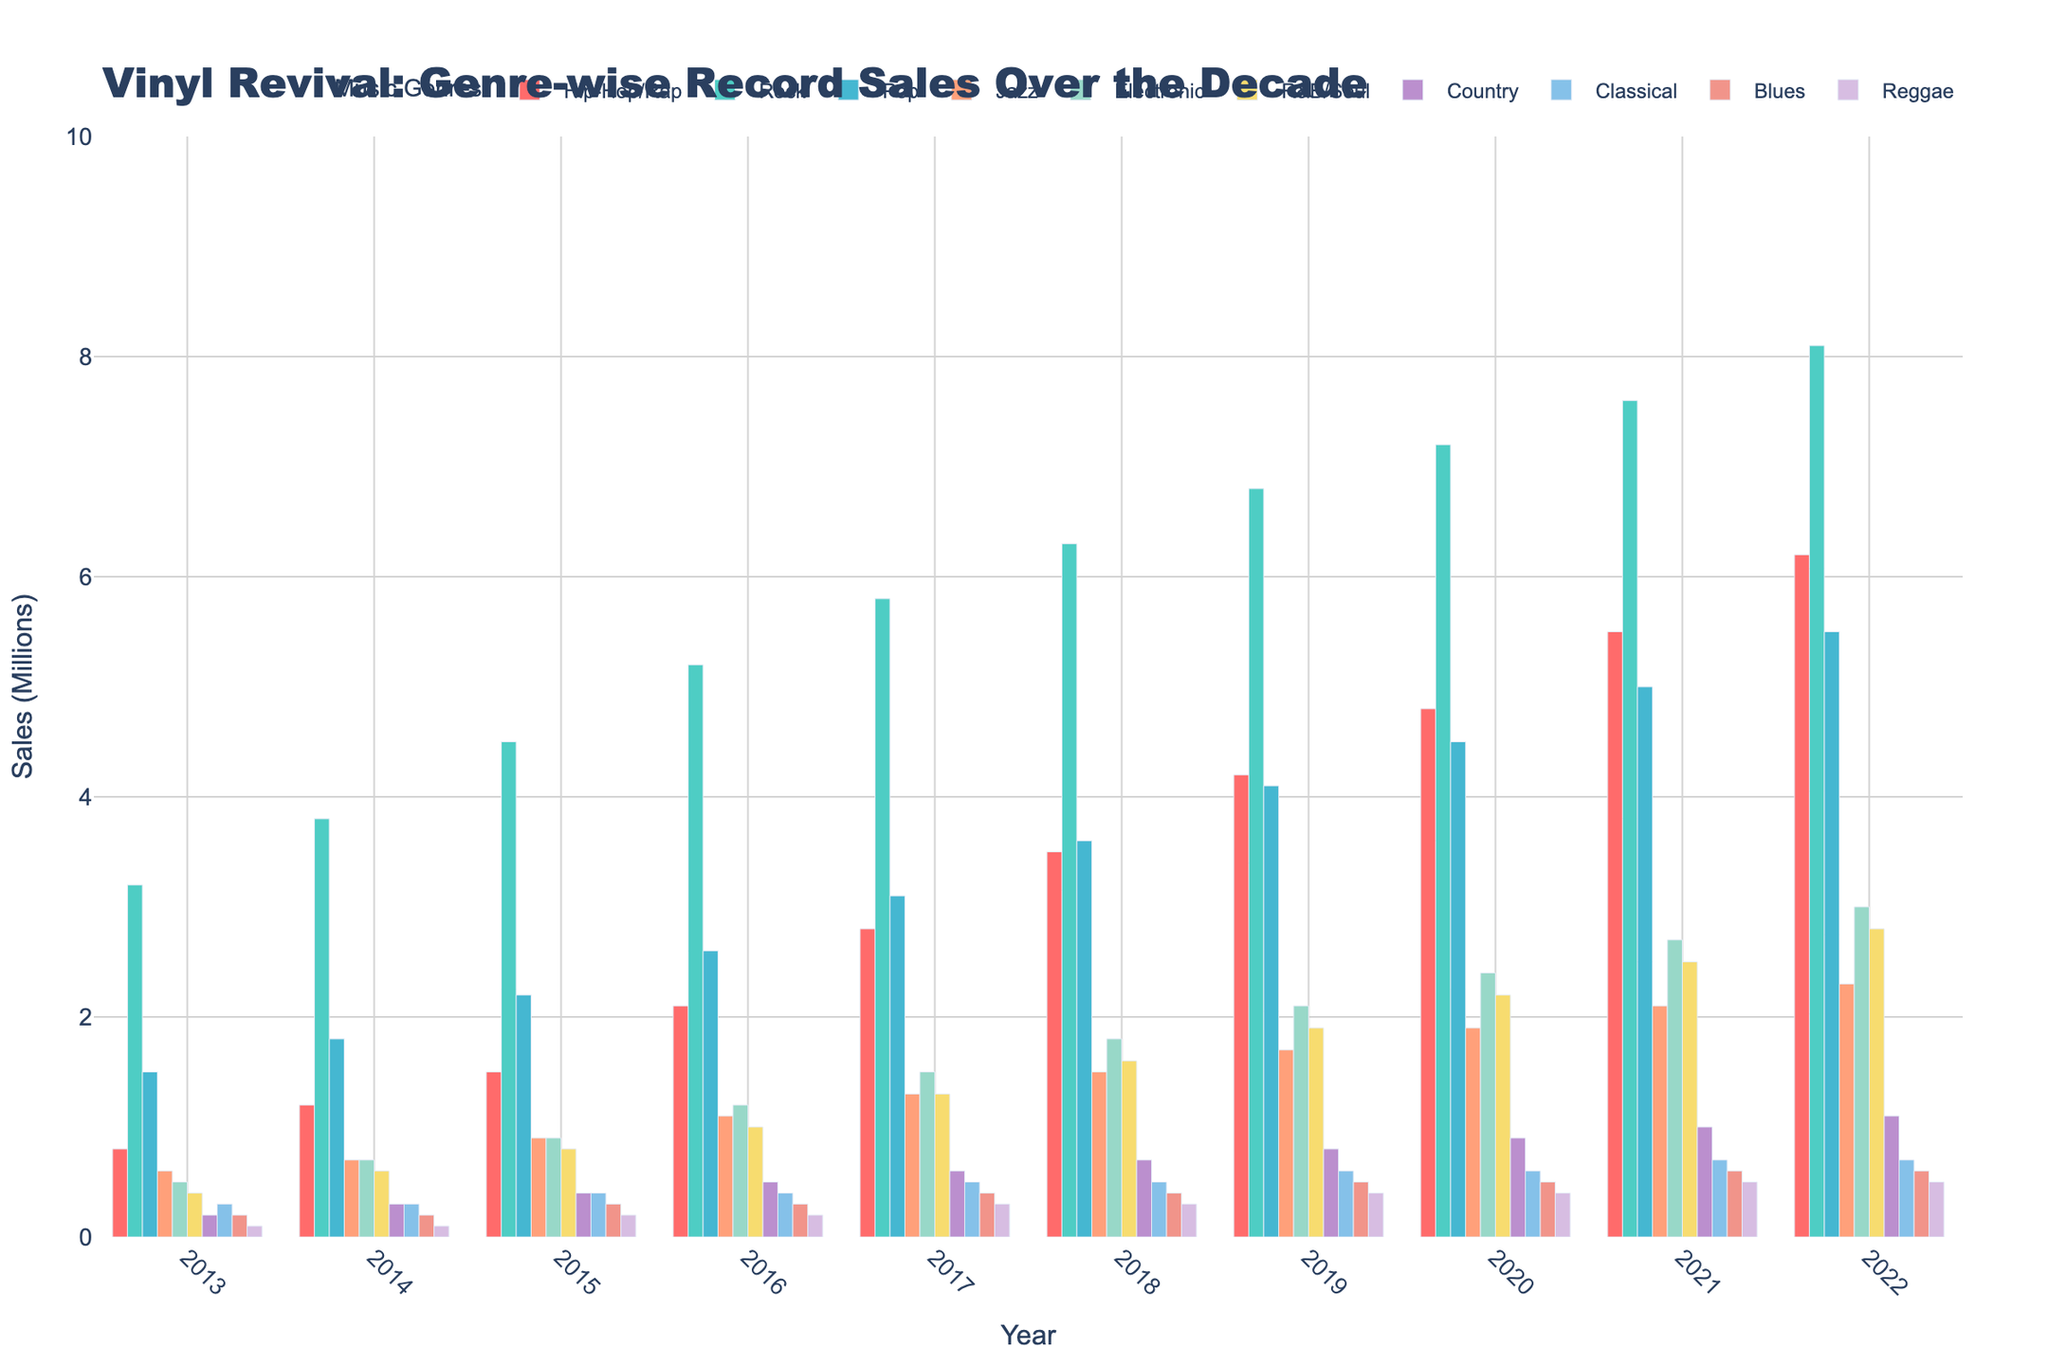Which genre saw the highest increase in vinyl sales from 2013 to 2022? To find the genre with the highest increase in sales, subtract the 2013 sales from the 2022 sales for each genre and compare the differences. Hip-Hop/Rap: 6.2 - 0.8 = 5.4 million, Rock: 8.1 - 3.2 = 4.9 million, and so on. The genre with the largest difference is Hip-Hop/Rap.
Answer: Hip-Hop/Rap How did Rock sales compare to Pop sales in 2020? Look at the figures for Rock and Pop in the year 2020. Rock sales were 7.2 million, and Pop sales were 4.5 million. Compare these two values.
Answer: Rock sales were higher Which genre had the least sales in 2015? Observe the height of the bars for each genre in 2015. The genre with the shortest bar represents the least sales. For 2015, the shortest bar is for Reggae, which is 0.2 million.
Answer: Reggae What was the average sales of Jazz records from 2013 to 2022? Sum up Jazz sales for all years from 2013 to 2022: 0.6 + 0.7 + 0.9 + 1.1 + 1.3 + 1.5 + 1.7 + 1.9 + 2.1 + 2.3 = 14.1 million. Then, divide by the number of years (10) to find the average: 14.1 / 10 = 1.41 million.
Answer: 1.41 million How did Electronic sales change between 2016 and 2018? Look at the Electronic sales figures for 2016 and 2018: 1.2 million and 1.8 million, respectively. Calculate the difference: 1.8 - 1.2 = 0.6 million increase.
Answer: Increased by 0.6 million Which genre had consistent year-over-year increases in sales? Compare the sales for each genre year by year from 2013 to 2022. Check if the sales for each genre increase each consecutive year. For example, Rock sales increased every year from 3.2 to 8.1 million. Other genres should be checked similarly.
Answer: Rock and Hip-Hop/Rap Which genre had the highest total sales over the entire decade? Sum the sales for each genre across all years (2013-2022). For example: Rock: 3.2 + 3.8 + 4.5 + 5.2 + 5.8 + 6.3 + 6.8 + 7.2 + 7.6 + 8.1 = 58.5 million. Compare totals for other genres to find Rock has the highest total.
Answer: Rock Did R&B/Soul sales ever surpass Jazz sales in any given year? Compare the R&B/Soul and Jazz bars year by year. In 2016 and 2017, both Jazz and R&B/Soul had equal sales, but Jazz always had at least equal or higher sales in all other years.
Answer: No What was the total vinyl sales for Reggae from 2014 to 2018? Sum the Reggae sales from 2014 to 2018: 0.1 + 0.2 + 0.2 + 0.3 + 0.3 = 1.1 million.
Answer: 1.1 million 